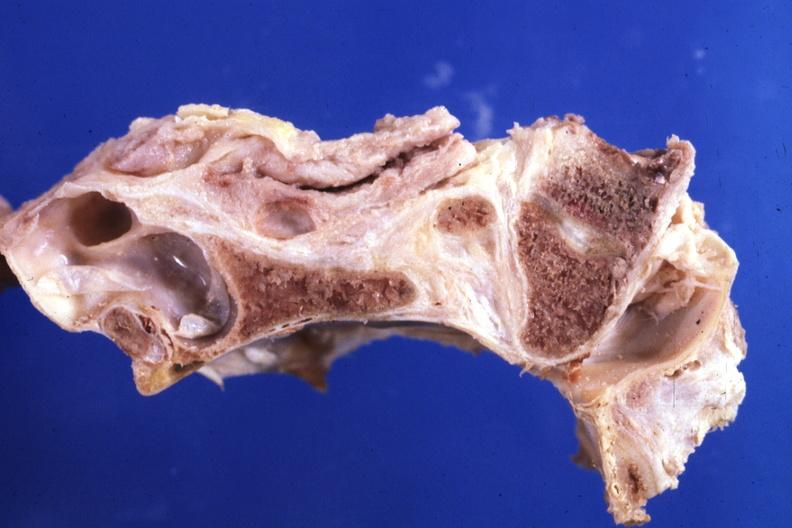what does this image show?
Answer the question using a single word or phrase. Fixed tissue saggital section stenotic foramen magnum 